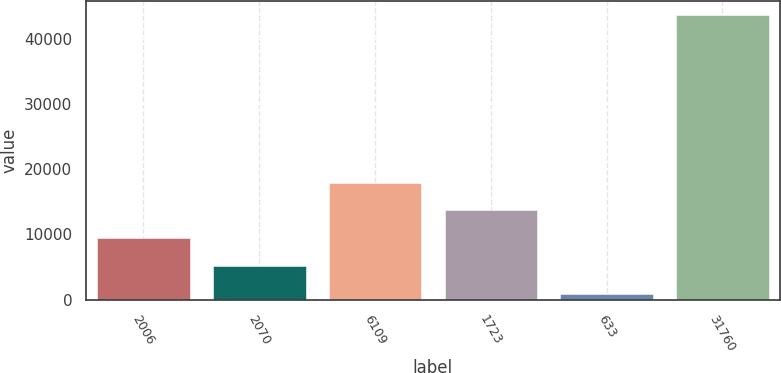<chart> <loc_0><loc_0><loc_500><loc_500><bar_chart><fcel>2006<fcel>2070<fcel>6109<fcel>1723<fcel>633<fcel>31760<nl><fcel>9389.4<fcel>5108.7<fcel>17950.8<fcel>13670.1<fcel>828<fcel>43635<nl></chart> 